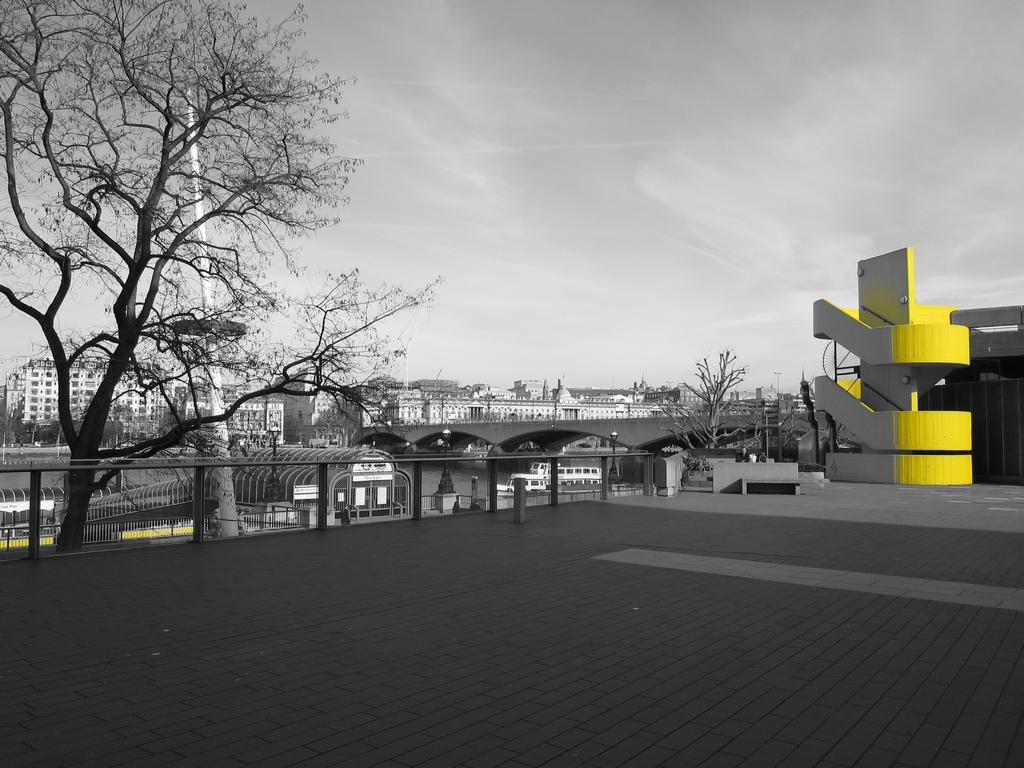What can be observed about the image in terms of editing? The image is edited. What type of structures can be seen in the image? There are buildings, a bridge, and a fence in the image. What type of vegetation is present in the image? There are trees in the image. What other objects can be seen in the image? There is a pole in the image. What part of the natural environment is visible in the image? The sky is visible at the top of the image, and there is a path visible at the bottom of the image. What type of yoke is being used to carry the lumber in the image? There is no yoke or lumber present in the image. How many rakes are visible in the image? There are no rakes visible in the image. 